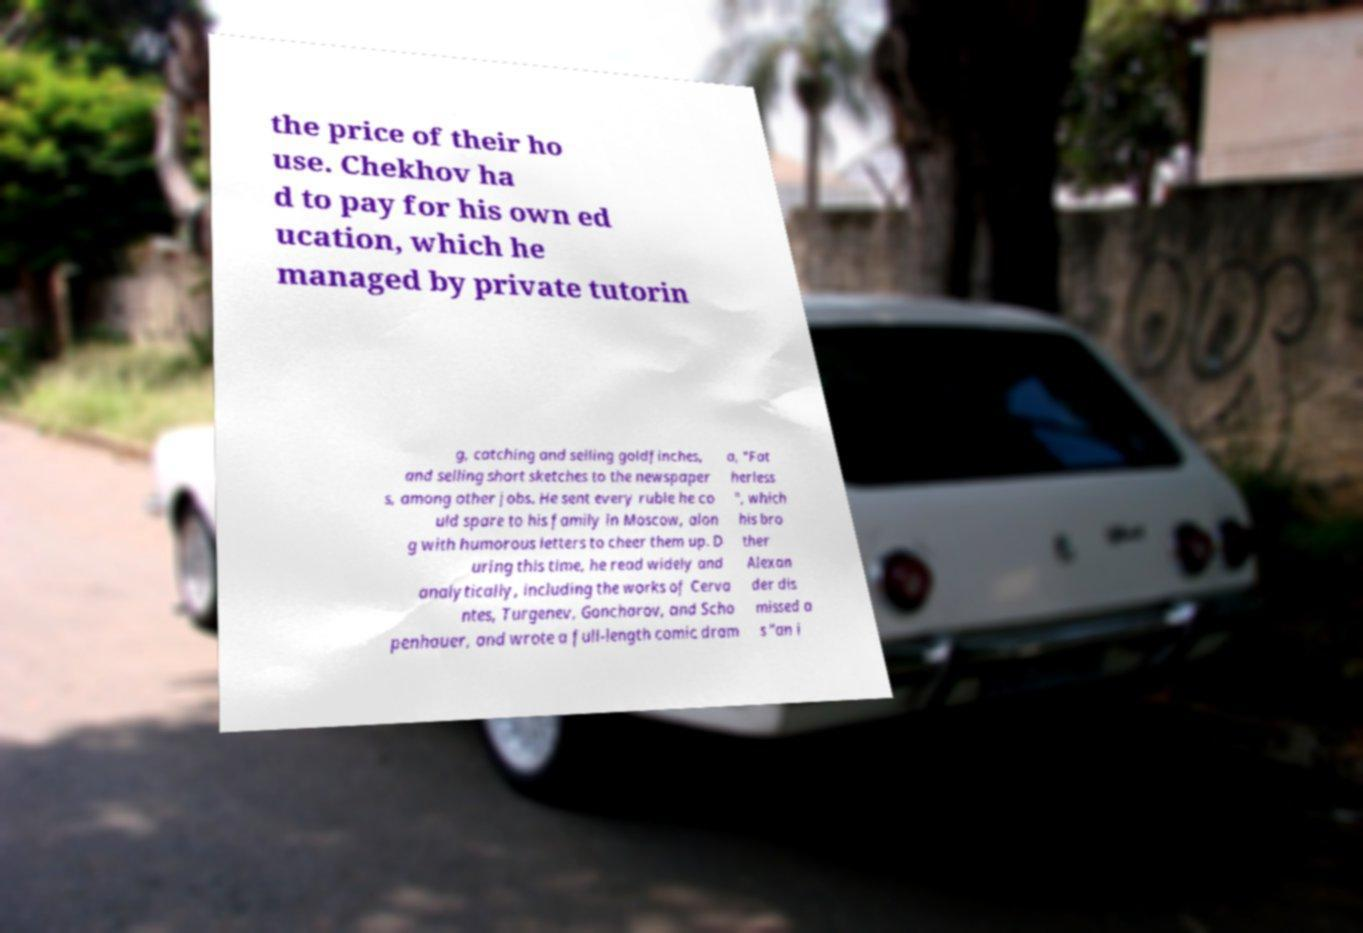What messages or text are displayed in this image? I need them in a readable, typed format. the price of their ho use. Chekhov ha d to pay for his own ed ucation, which he managed by private tutorin g, catching and selling goldfinches, and selling short sketches to the newspaper s, among other jobs. He sent every ruble he co uld spare to his family in Moscow, alon g with humorous letters to cheer them up. D uring this time, he read widely and analytically, including the works of Cerva ntes, Turgenev, Goncharov, and Scho penhauer, and wrote a full-length comic dram a, "Fat herless ", which his bro ther Alexan der dis missed a s "an i 